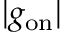Convert formula to latex. <formula><loc_0><loc_0><loc_500><loc_500>| g _ { o n } |</formula> 